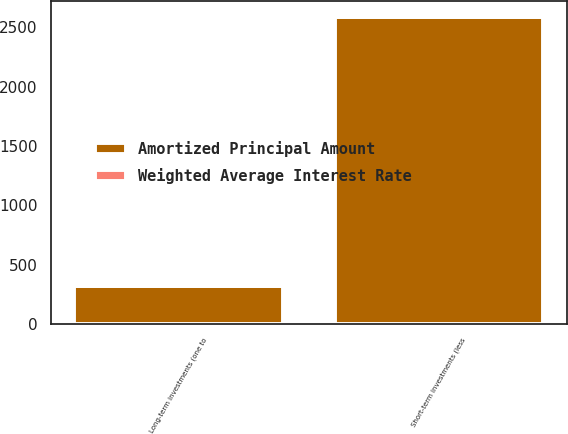<chart> <loc_0><loc_0><loc_500><loc_500><stacked_bar_chart><ecel><fcel>Short-term investments (less<fcel>Long-term investments (one to<nl><fcel>Amortized Principal Amount<fcel>2588<fcel>318<nl><fcel>Weighted Average Interest Rate<fcel>5.68<fcel>5.68<nl></chart> 